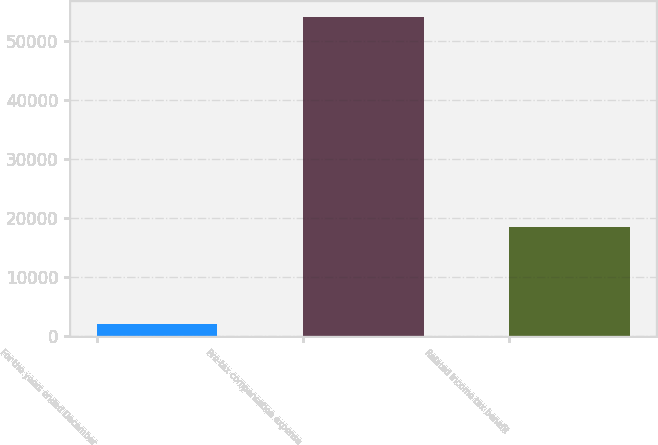Convert chart to OTSL. <chart><loc_0><loc_0><loc_500><loc_500><bar_chart><fcel>For the years ended December<fcel>Pre-tax compensation expense<fcel>Related income tax benefit<nl><fcel>2013<fcel>53984<fcel>18517<nl></chart> 